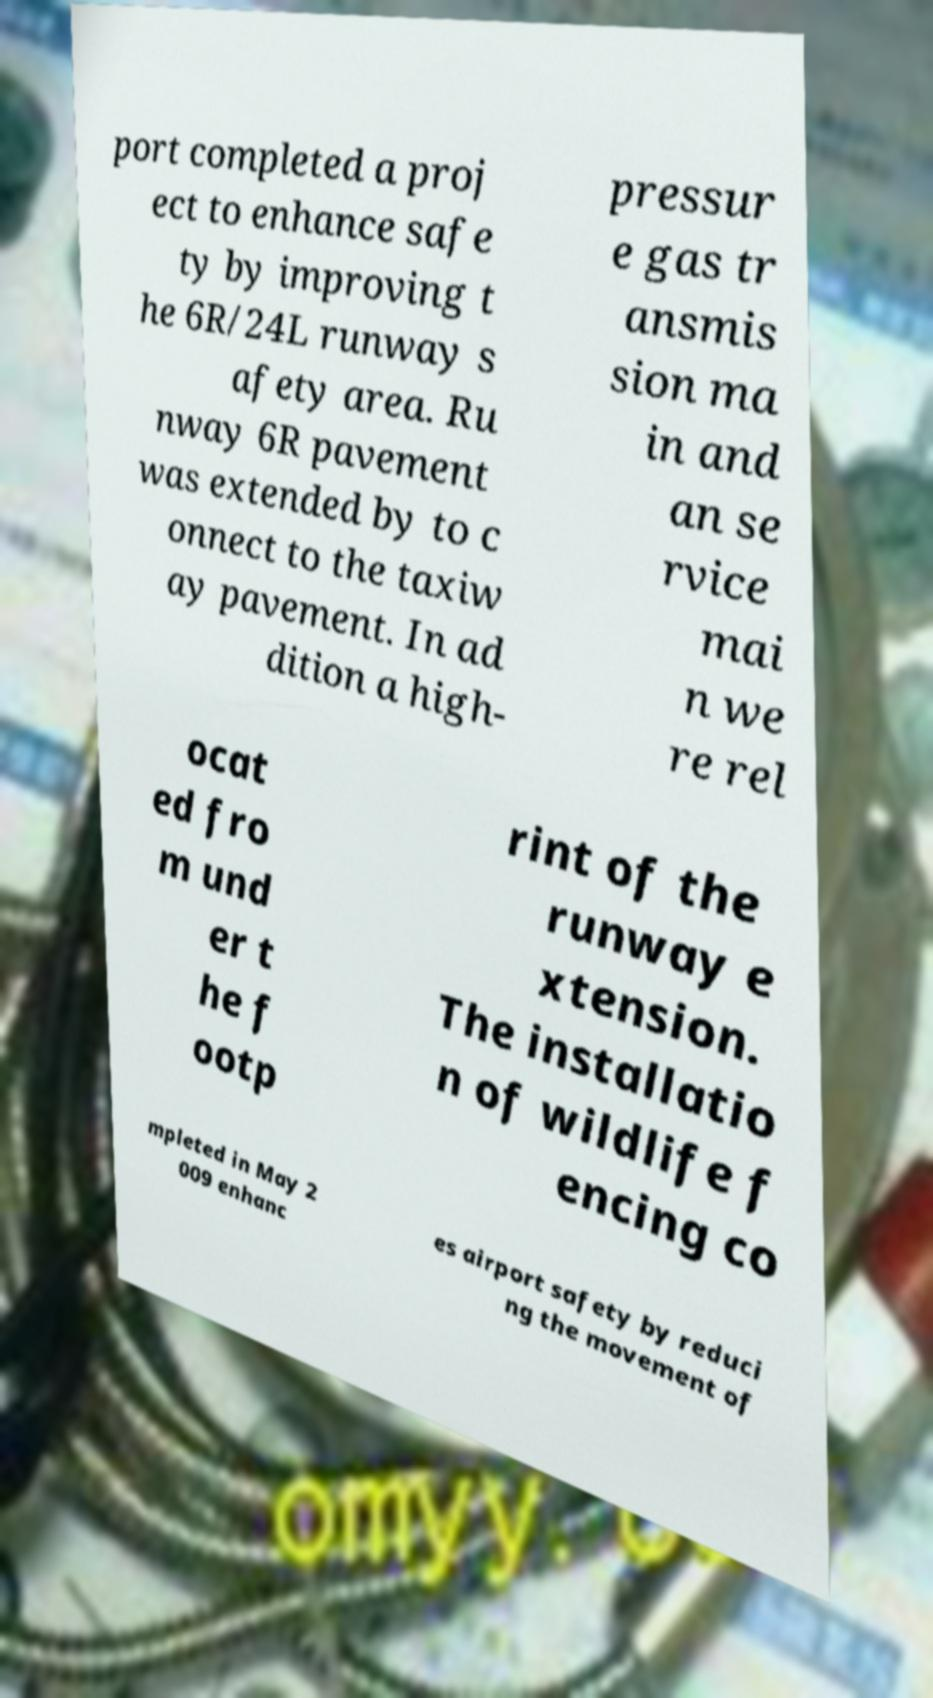Could you assist in decoding the text presented in this image and type it out clearly? port completed a proj ect to enhance safe ty by improving t he 6R/24L runway s afety area. Ru nway 6R pavement was extended by to c onnect to the taxiw ay pavement. In ad dition a high- pressur e gas tr ansmis sion ma in and an se rvice mai n we re rel ocat ed fro m und er t he f ootp rint of the runway e xtension. The installatio n of wildlife f encing co mpleted in May 2 009 enhanc es airport safety by reduci ng the movement of 